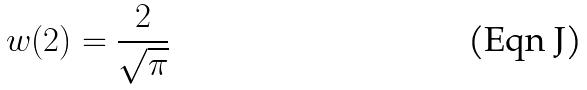<formula> <loc_0><loc_0><loc_500><loc_500>w ( 2 ) = \frac { 2 } { \sqrt { \pi } }</formula> 